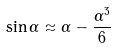<formula> <loc_0><loc_0><loc_500><loc_500>\sin \alpha \approx \alpha - \frac { \alpha ^ { 3 } } { 6 }</formula> 